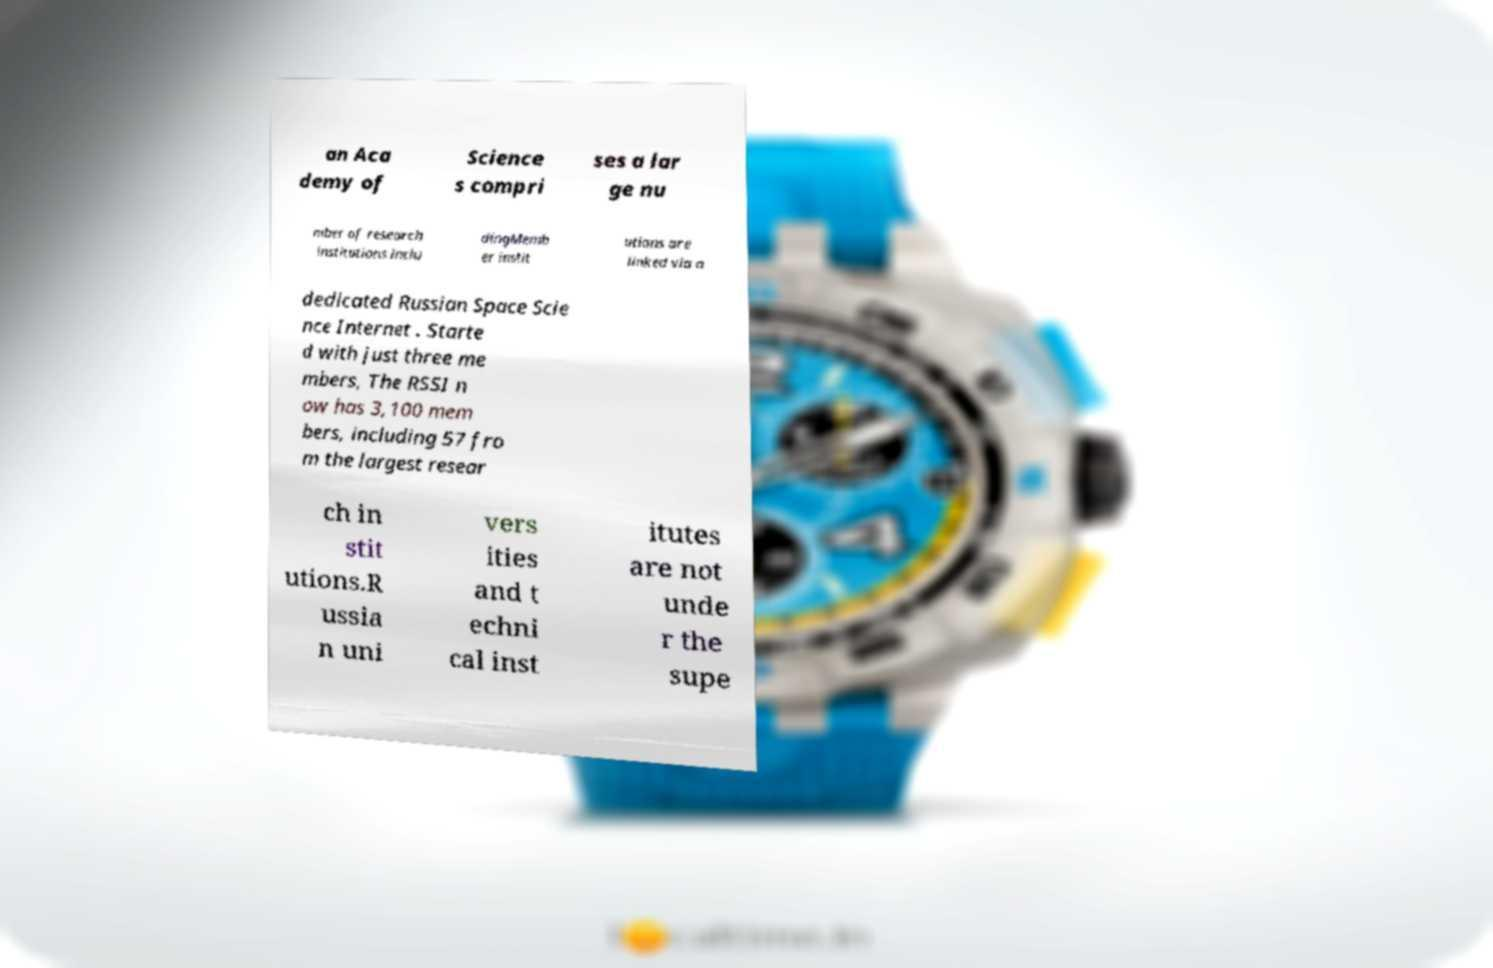Can you accurately transcribe the text from the provided image for me? an Aca demy of Science s compri ses a lar ge nu mber of research institutions inclu dingMemb er instit utions are linked via a dedicated Russian Space Scie nce Internet . Starte d with just three me mbers, The RSSI n ow has 3,100 mem bers, including 57 fro m the largest resear ch in stit utions.R ussia n uni vers ities and t echni cal inst itutes are not unde r the supe 